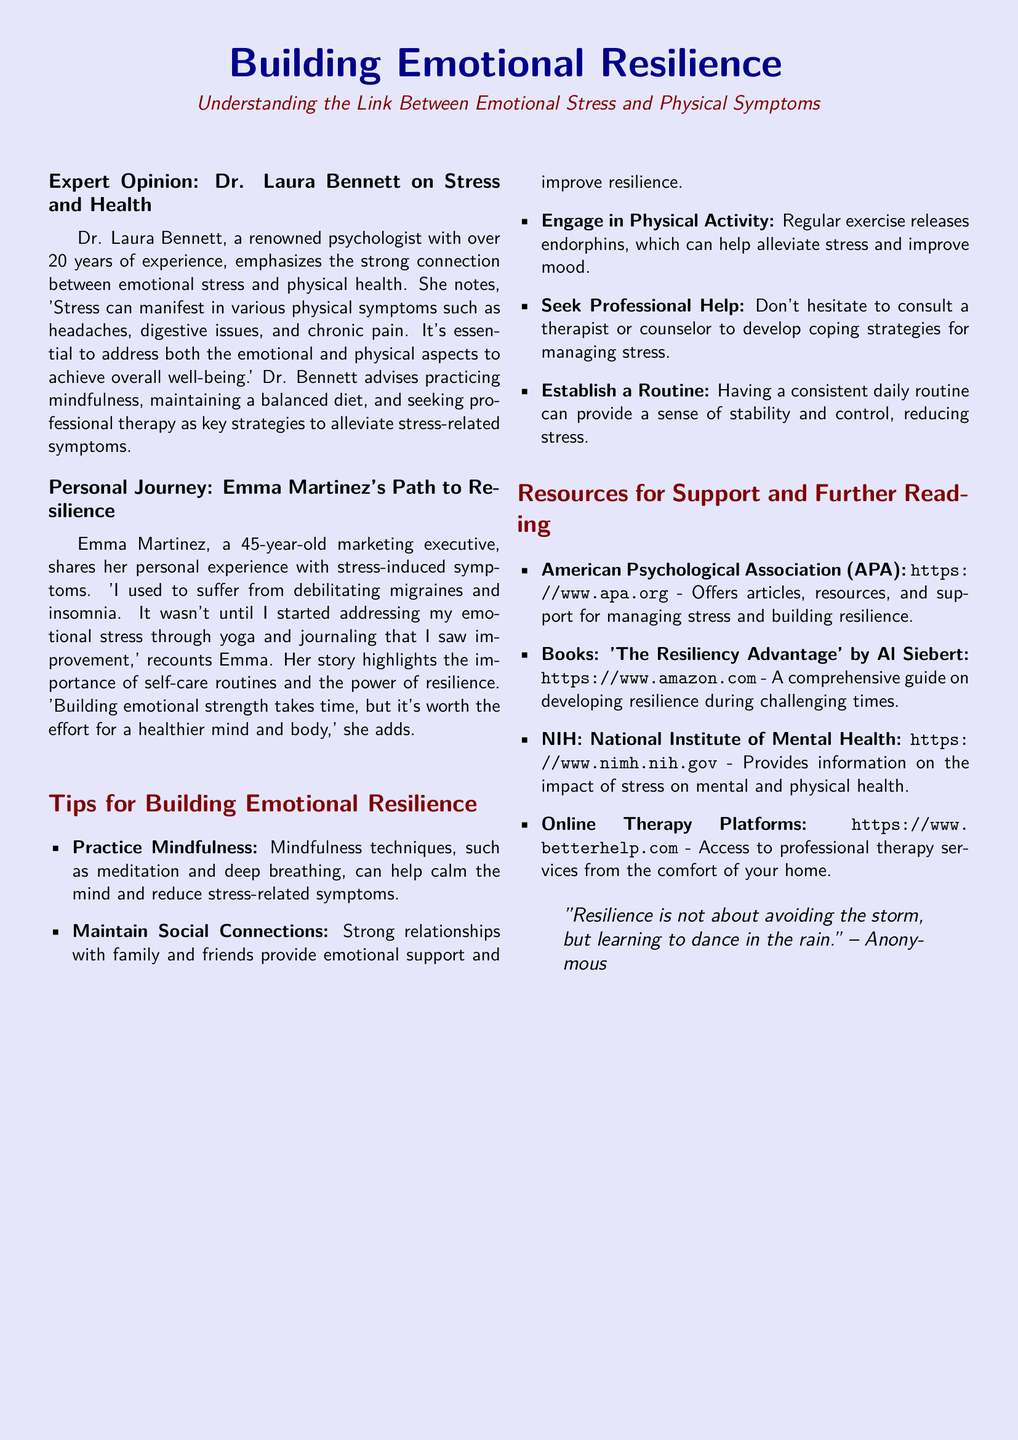What is the occupation of Dr. Laura Bennett? Dr. Laura Bennett is described as a psychologist with over 20 years of experience.
Answer: psychologist What symptoms did Emma Martinez experience? Emma Martinez mentions suffering from debilitating migraines and insomnia.
Answer: migraines and insomnia What is one recommended strategy from Dr. Bennett for alleviating stress? Dr. Bennett advises practicing mindfulness as a key strategy to address stress-related symptoms.
Answer: practicing mindfulness How old is Emma Martinez? Emma Martinez is specifically stated to be 45 years old.
Answer: 45 Which color is used for the page background? The document indicates that the page color is lavender.
Answer: lavender What does the quote at the bottom of the page suggest about resilience? The quote suggests that resilience involves adapting to challenges rather than avoiding them.
Answer: learning to dance in the rain Name one resource mentioned for further reading. The document lists the American Psychological Association (APA) as a resource for managing stress.
Answer: American Psychological Association What type of activity is suggested to help alleviate stress? Engaging in physical activity is recommended to relieve stress.
Answer: physical activity Who is the author of the book mentioned in the resources section? The author of the book "The Resiliency Advantage" is Al Siebert.
Answer: Al Siebert 